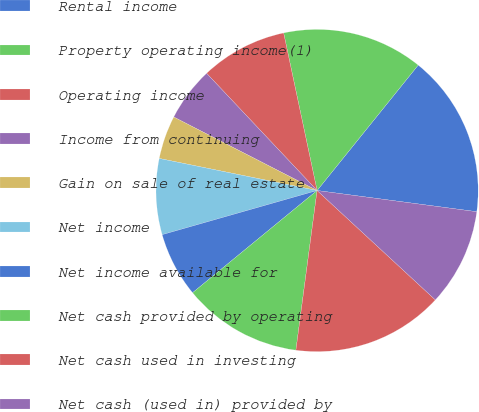Convert chart. <chart><loc_0><loc_0><loc_500><loc_500><pie_chart><fcel>Rental income<fcel>Property operating income(1)<fcel>Operating income<fcel>Income from continuing<fcel>Gain on sale of real estate<fcel>Net income<fcel>Net income available for<fcel>Net cash provided by operating<fcel>Net cash used in investing<fcel>Net cash (used in) provided by<nl><fcel>16.3%<fcel>14.13%<fcel>8.7%<fcel>5.43%<fcel>4.35%<fcel>7.61%<fcel>6.52%<fcel>11.96%<fcel>15.22%<fcel>9.78%<nl></chart> 